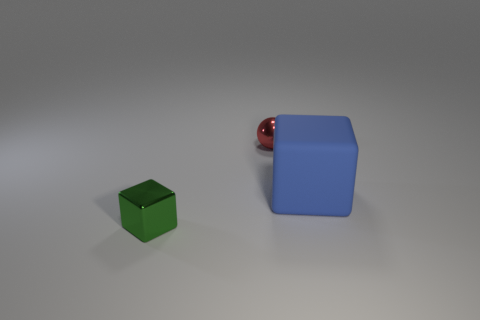Add 2 matte blocks. How many objects exist? 5 Subtract all blocks. How many objects are left? 1 Subtract all green blocks. Subtract all big cubes. How many objects are left? 1 Add 2 big matte cubes. How many big matte cubes are left? 3 Add 3 small red metal spheres. How many small red metal spheres exist? 4 Subtract 0 blue cylinders. How many objects are left? 3 